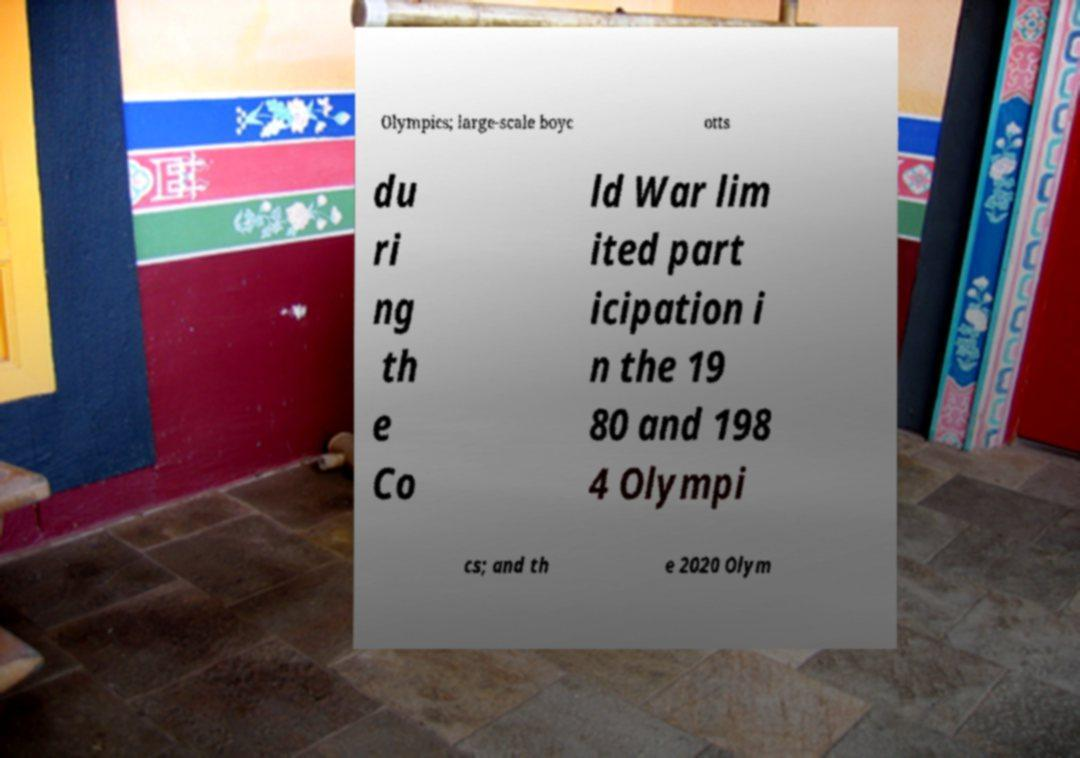Can you read and provide the text displayed in the image?This photo seems to have some interesting text. Can you extract and type it out for me? Olympics; large-scale boyc otts du ri ng th e Co ld War lim ited part icipation i n the 19 80 and 198 4 Olympi cs; and th e 2020 Olym 